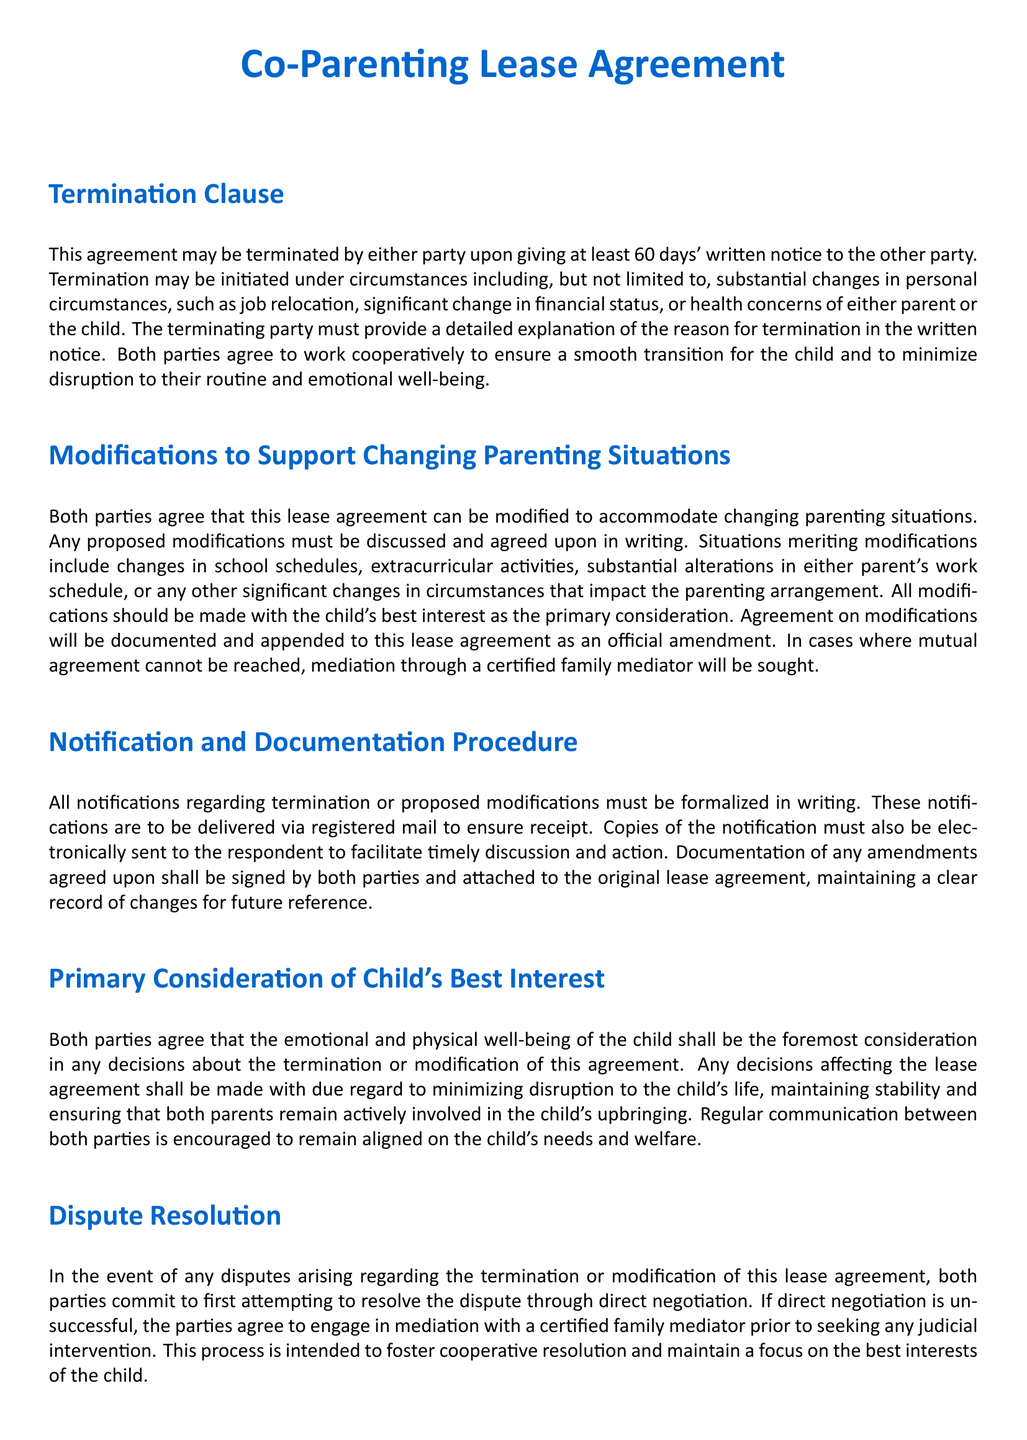What is the notice period for termination? The notice period stated in the document for termination of the agreement is at least 60 days.
Answer: 60 days What must be included in the written notice of termination? The written notice of termination must include a detailed explanation of the reason for termination.
Answer: Detailed explanation What are some circumstances under which the agreement can be terminated? The document outlines that termination can occur due to substantial changes such as job relocation, financial status changes, or health concerns.
Answer: Job relocation, financial status changes, health concerns What is required to modify the lease agreement? Proposed modifications to the lease agreement must be discussed and agreed upon in writing.
Answer: Discussed and agreed upon in writing Who will mediate if the parties cannot reach an agreement? The document states that a certified family mediator will be sought if mutual agreement cannot be reached.
Answer: Certified family mediator What should be the primary consideration in decisions about termination or modification? The primary consideration for any decisions made regarding the lease agreement should be the emotional and physical well-being of the child.
Answer: Child's best interest How should notifications regarding termination or modifications be delivered? Notifications are to be delivered via registered mail to ensure receipt.
Answer: Registered mail What is the first step in case of a dispute regarding the agreement? Direct negotiation is the first step recommended in the case of a dispute arising from the agreement.
Answer: Direct negotiation 